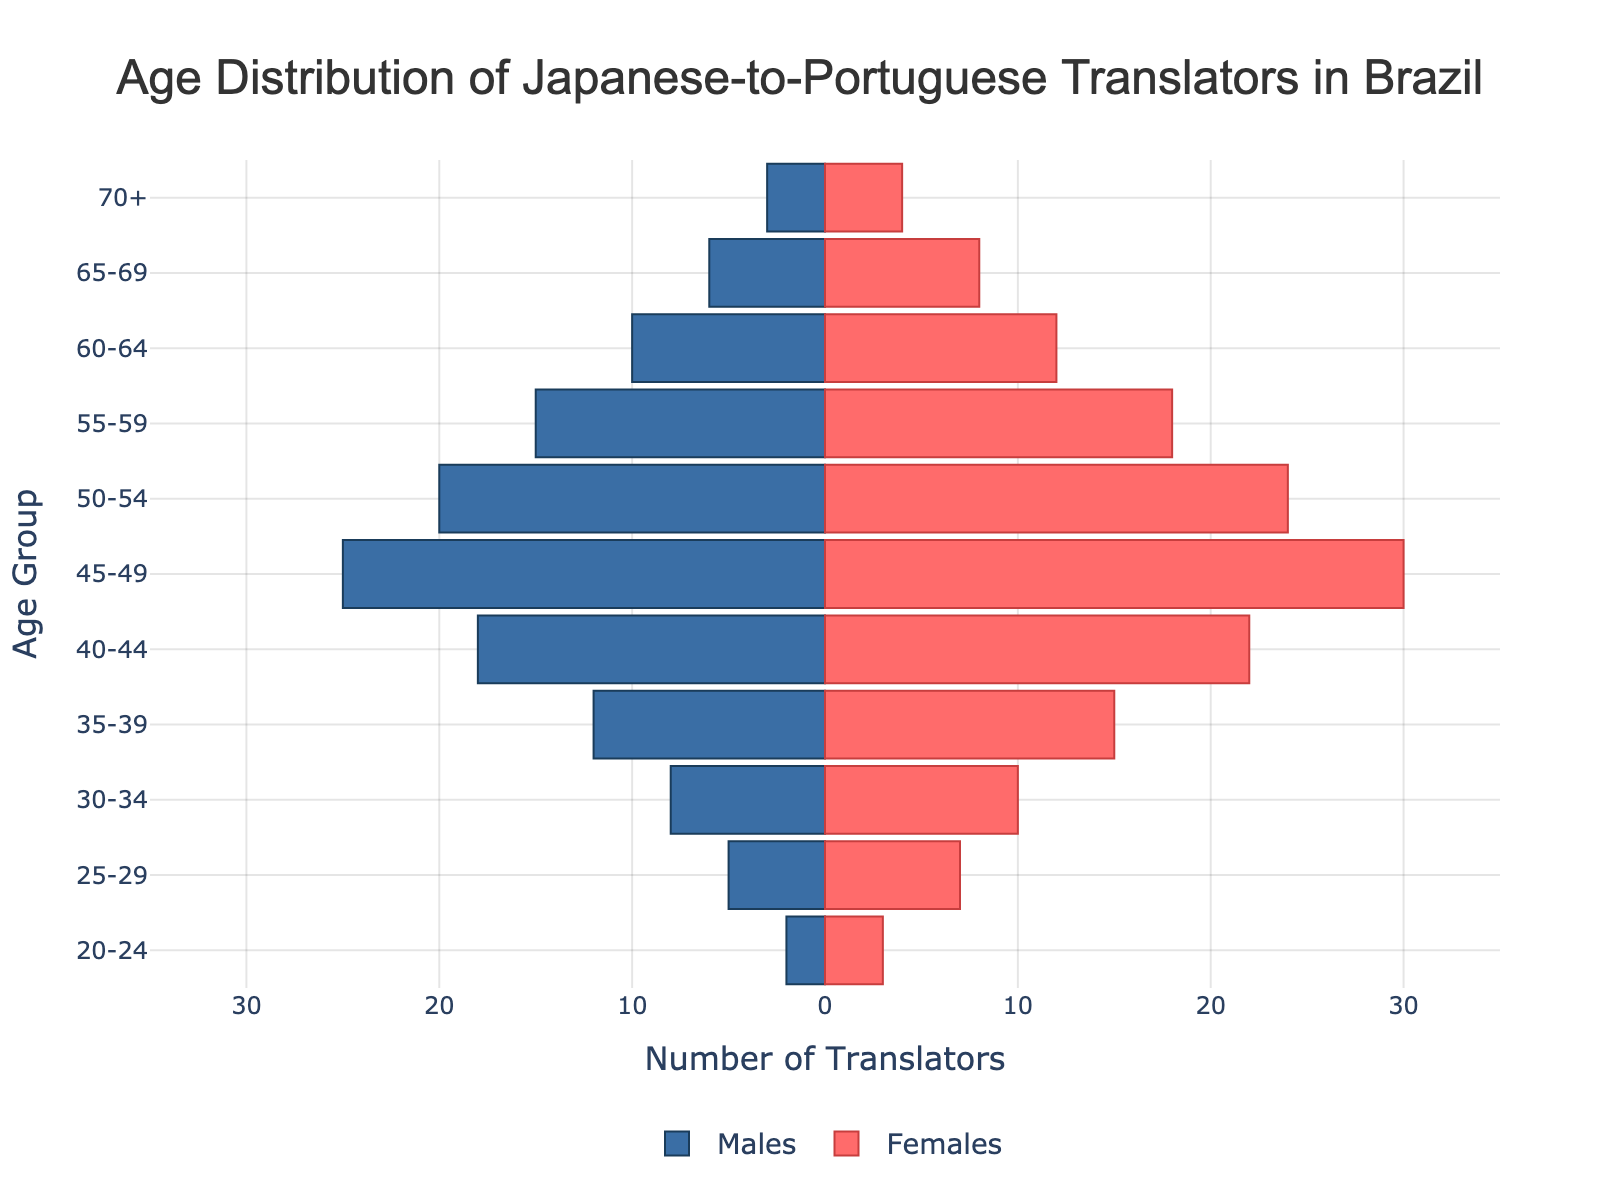What is the age group with the highest number of female translators? The female bar with the longest positive value corresponds to the "45-49" age group, reaching up to 30 translators.
Answer: 45-49 How many male translators are there in the 50-54 age group? The "50-54" bar extends to -20 for males, which means there are 20 male translators in this age group.
Answer: 20 What is the total number of translators in the 40-44 age group? The number of male translators in the 40-44 age group is 18 and the number of female translators is 22. So, the total is 18 + 22 = 40.
Answer: 40 Which gender has more translators in the 25-29 age group and by how much? There are 5 male translators and 7 female translators in the 25-29 age group. The difference is 7 - 5 = 2.
Answer: Females, by 2 In which age group do males significantly outnumber females? Comparing all bars, the 45-49 age group shows males (25) outnumbering females (30) by the smallest margin of 5.
Answer: 45-49 What is the total number of female translators in the 55-59 and 60-64 age groups combined? The number of female translators in the 55-59 age group is 18, and in the 60-64 age group, it is 12. So, the combined total is 18 + 12 = 30.
Answer: 30 What is the age group with the least number of translators overall? Both males (3) and females (4) in the "70+" age group have the least counts, totaling 3 + 4 = 7.
Answer: 70+ What is the ratio of male to female translators in the 35-39 age group? In the 35-39 age group, there are 12 male translators and 15 female translators. The ratio is 12:15, which reduces to 4:5.
Answer: 4:5 Which two age groups have the exact same number of female translators, and what is that number? The 55-59 and 60-64 age groups both have 18 and 12 female translators, respectively, though neither matches in number. Hence, none match exactly.
Answer: None How many more male translators are there than female translators in the 50-54 age group? In the 50-54 age group, there are 20 male translators and 24 female translators. The number of males is fewer than females by 24 - 20 = 4.
Answer: Females by 4 